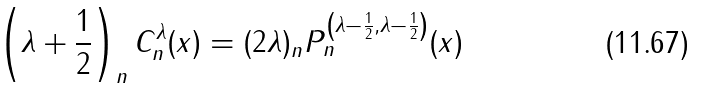Convert formula to latex. <formula><loc_0><loc_0><loc_500><loc_500>\left ( \lambda + \frac { 1 } { 2 } \right ) _ { n } C _ { n } ^ { \lambda } ( x ) = ( 2 \lambda ) _ { n } P _ { n } ^ { \left ( \lambda - \frac { 1 } { 2 } , \lambda - \frac { 1 } { 2 } \right ) } ( x )</formula> 